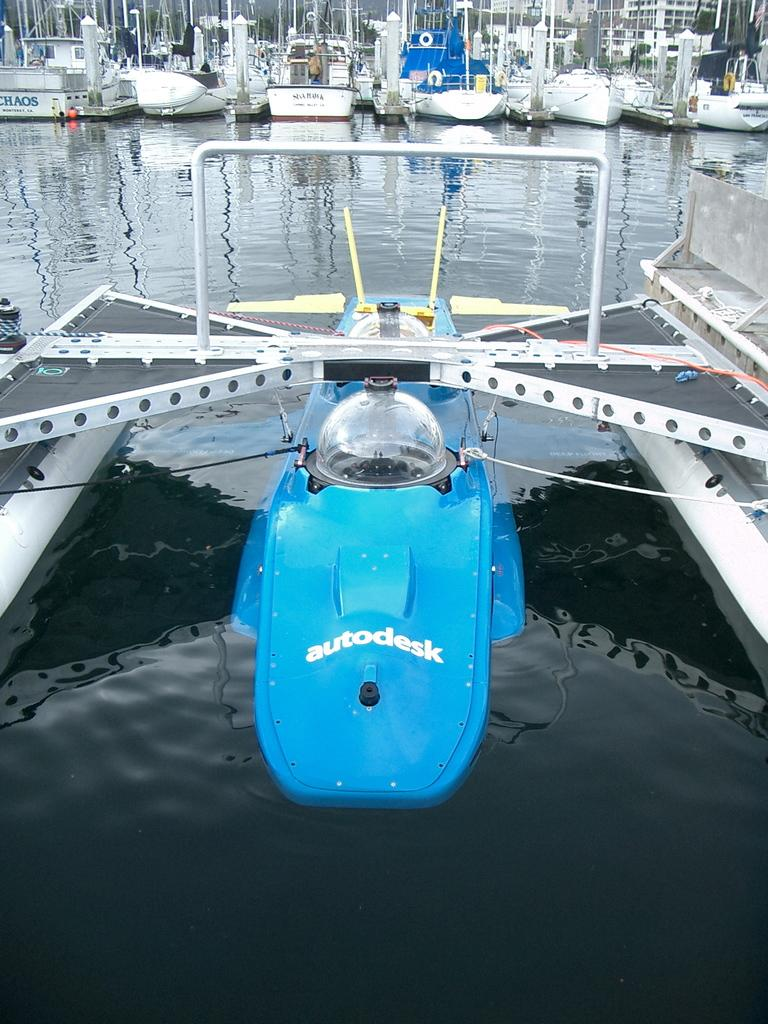<image>
Relay a brief, clear account of the picture shown. Autodesk is docked at a marina with more conventional boats behind it. 